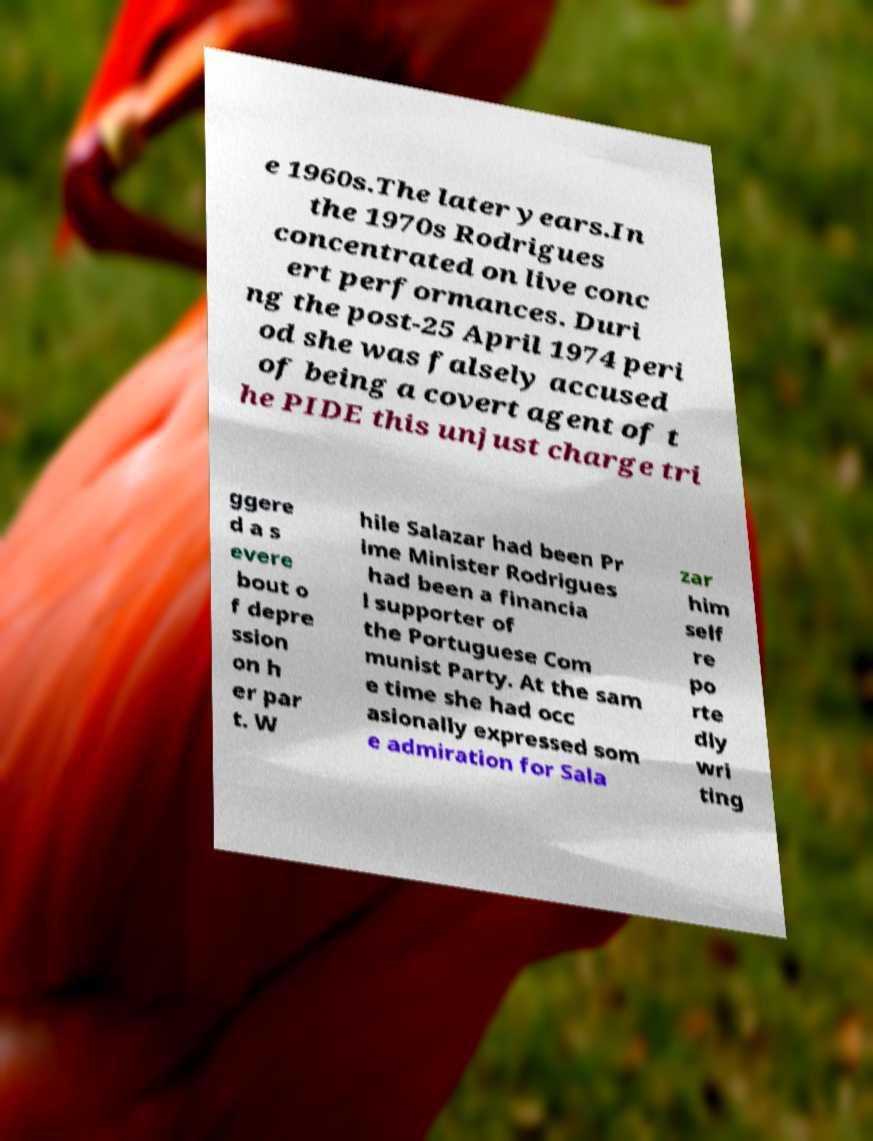Please read and relay the text visible in this image. What does it say? e 1960s.The later years.In the 1970s Rodrigues concentrated on live conc ert performances. Duri ng the post-25 April 1974 peri od she was falsely accused of being a covert agent of t he PIDE this unjust charge tri ggere d a s evere bout o f depre ssion on h er par t. W hile Salazar had been Pr ime Minister Rodrigues had been a financia l supporter of the Portuguese Com munist Party. At the sam e time she had occ asionally expressed som e admiration for Sala zar him self re po rte dly wri ting 